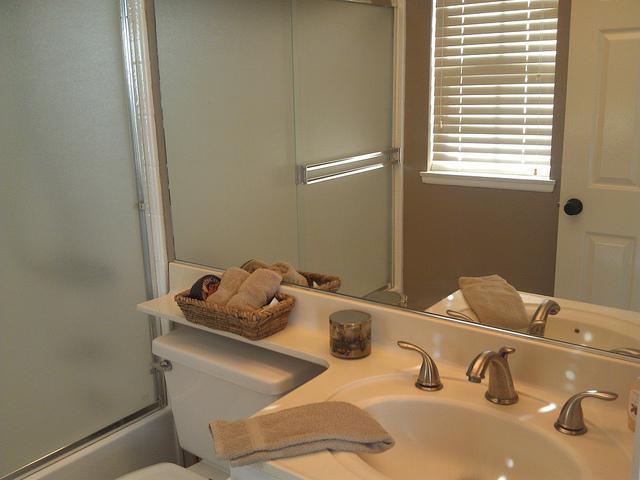How many giraffes are there?
Give a very brief answer. 0. 